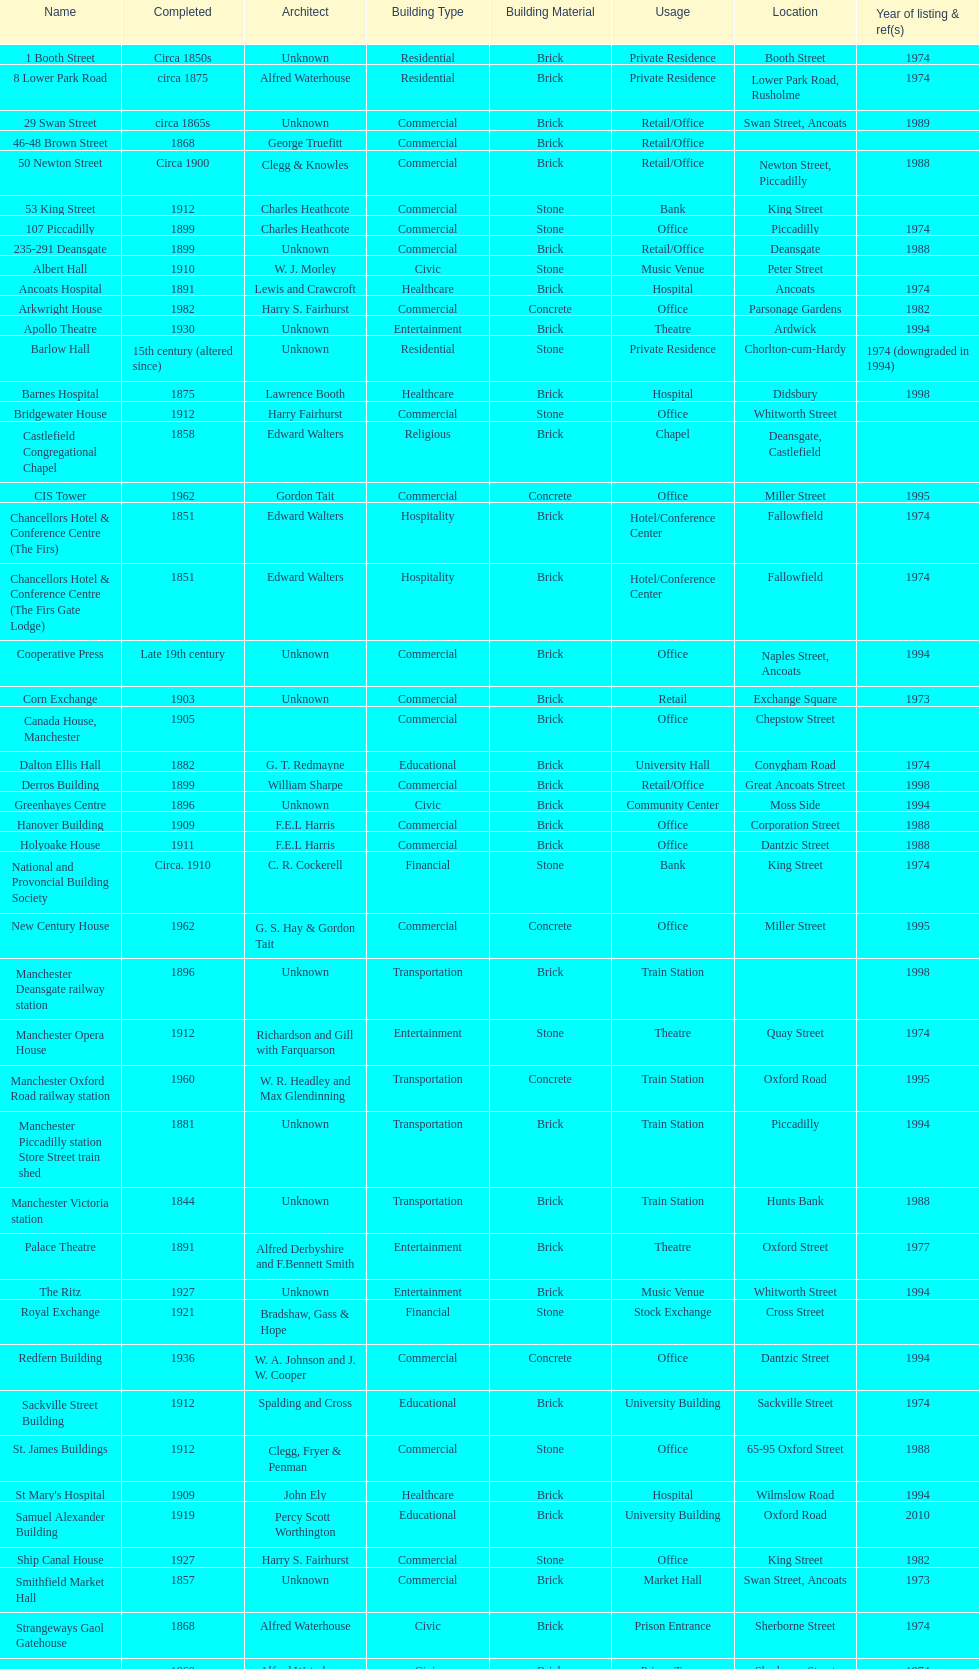Which two buildings were listed before 1974? The Old Wellington Inn, Smithfield Market Hall. 